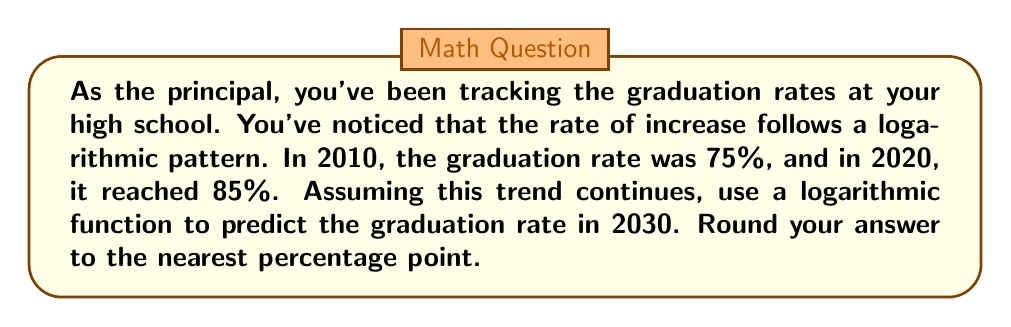Give your solution to this math problem. Let's approach this step-by-step:

1) We can model this situation with a logarithmic function of the form:
   $$ y = a \ln(x) + b $$
   where $y$ is the graduation rate and $x$ is the number of years since 2010.

2) We have two points to work with:
   (0, 75) for 2010 and (10, 85) for 2020

3) Let's plug these into our equation:
   75 = $a \ln(1) + b$  (note: $\ln(1) = 0$)
   85 = $a \ln(11) + b$

4) From the first equation:
   $b = 75$

5) Substituting this into the second equation:
   85 = $a \ln(11) + 75$
   10 = $a \ln(11)$
   $a = \frac{10}{\ln(11)} \approx 4.3429$

6) Our function is therefore:
   $$ y = 4.3429 \ln(x+1) + 75 $$

7) To predict the rate for 2030, we plug in $x = 20$:
   $$ y = 4.3429 \ln(21) + 75 \approx 89.7 $$

8) Rounding to the nearest percentage point gives us 90%.
Answer: 90% 